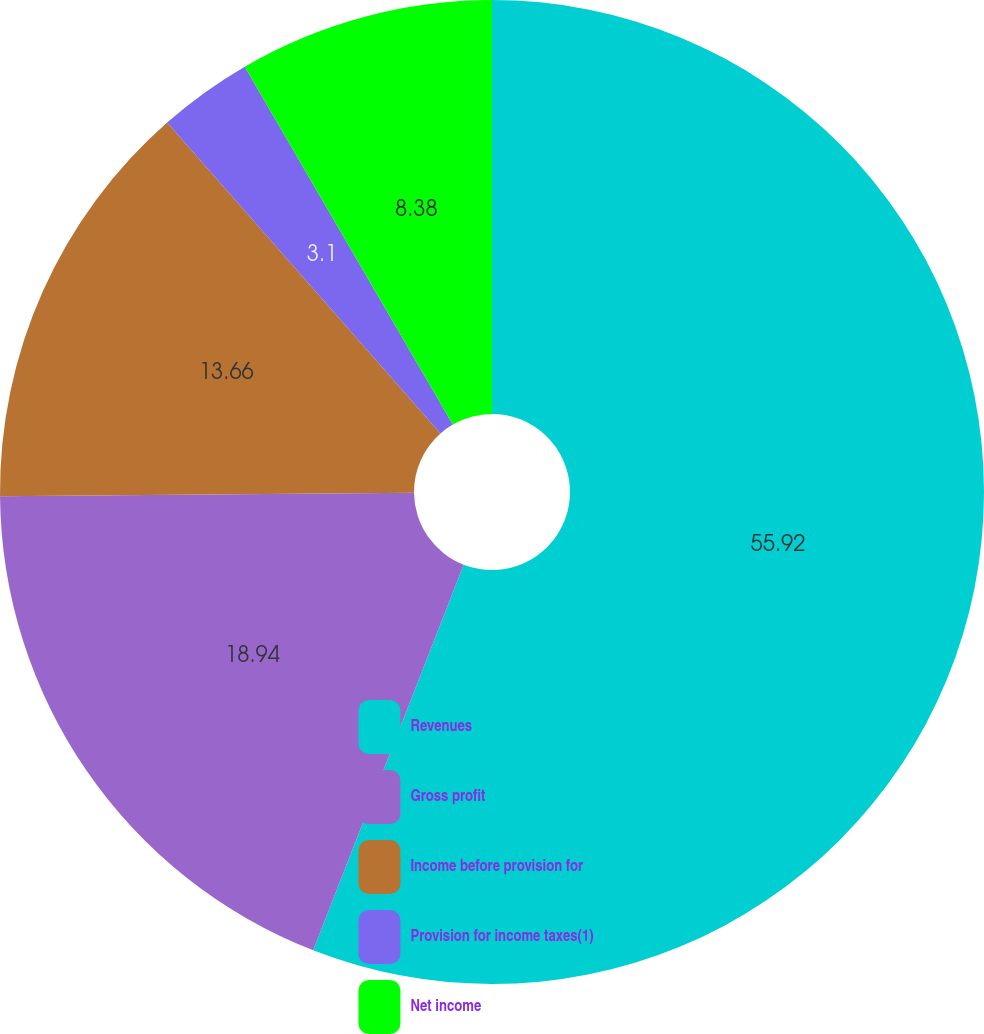<chart> <loc_0><loc_0><loc_500><loc_500><pie_chart><fcel>Revenues<fcel>Gross profit<fcel>Income before provision for<fcel>Provision for income taxes(1)<fcel>Net income<nl><fcel>55.92%<fcel>18.94%<fcel>13.66%<fcel>3.1%<fcel>8.38%<nl></chart> 